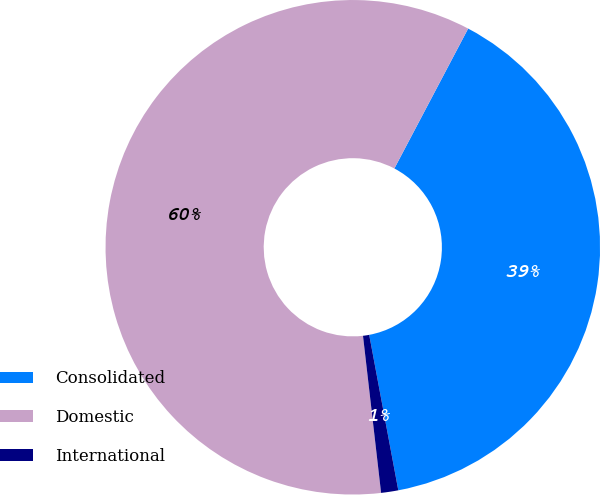Convert chart to OTSL. <chart><loc_0><loc_0><loc_500><loc_500><pie_chart><fcel>Consolidated<fcel>Domestic<fcel>International<nl><fcel>39.33%<fcel>59.55%<fcel>1.12%<nl></chart> 